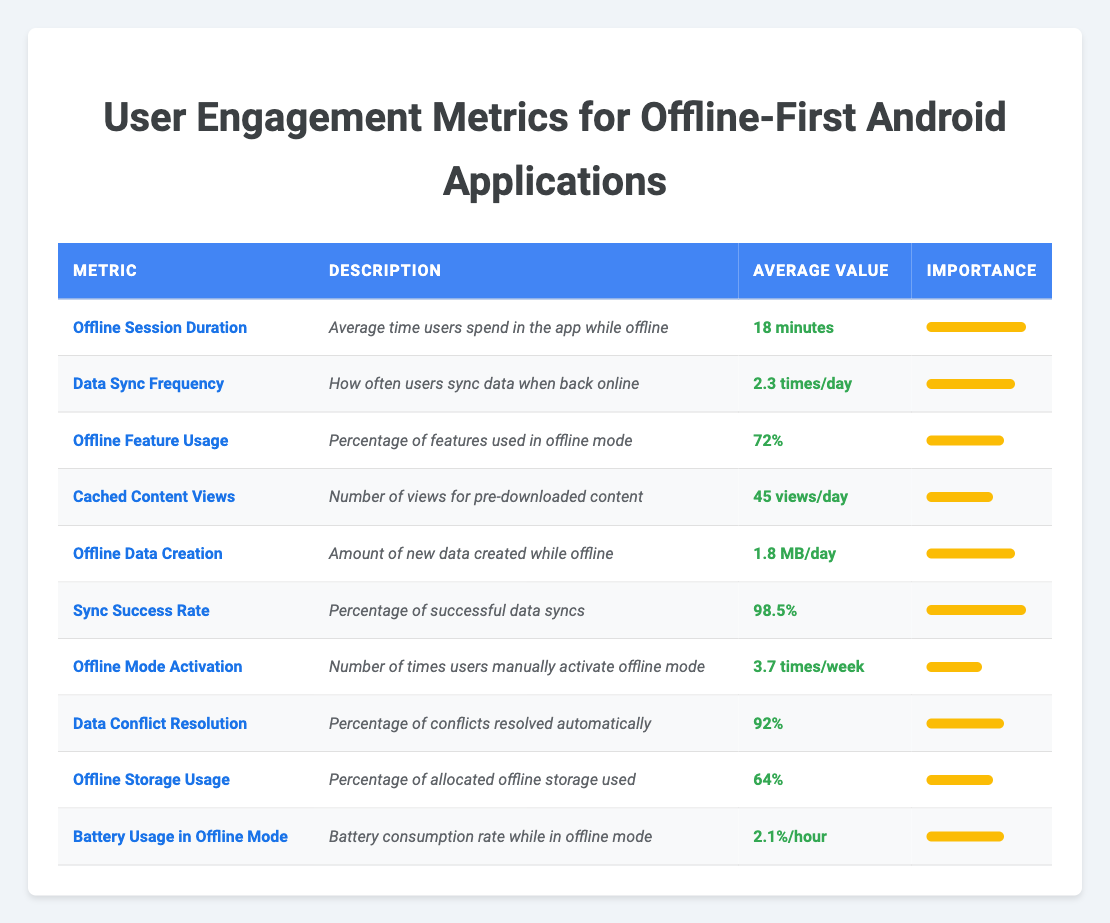What is the average value of Offline Session Duration? The average value for Offline Session Duration is provided directly in the table, which states it as "18 minutes."
Answer: 18 minutes How often do users sync data when back online (Data Sync Frequency)? The Data Sync Frequency is clearly listed in the table as "2.3 times/day." There are no calculations needed for this retrieval question.
Answer: 2.3 times/day Is the Sync Success Rate greater than or equal to 95%? The table shows the Sync Success Rate as "98.5%," which is indeed greater than 95%. Therefore, the answer is yes.
Answer: Yes What percentage of features are used in offline mode? According to the table, the Offline Feature Usage is "72%," which is a direct retrieval from the visual information.
Answer: 72% What is the difference in average values between Offline Session Duration and Cached Content Views? The Offline Session Duration is "18 minutes," while Cached Content Views is given as "45 views/day." To find the difference, note that one is in minutes and the other in views per day, so a direct subtraction isn't applicable. However, we can see that both metrics reflect user engagement in different ways. Hence, one can't compute a numerical difference directly. Thus no numeric value is provided for this question.
Answer: Not computable due to differing units How much new data is created daily while offline (Offline Data Creation)? In the table, the Offline Data Creation metric is listed as "1.8 MB/day," which is directly retrievable information.
Answer: 1.8 MB/day What is the average value of Offline Mode Activation per week? The value shown for Offline Mode Activation is "3.7 times/week," which presents a straightforward retrieval from the table.
Answer: 3.7 times/week What is the average battery usage in offline mode per hour? The table specifies the Battery Usage in Offline Mode as "2.1%/hour," making this a simple retrieval question.
Answer: 2.1%/hour Is the percentage of Automatic Data Conflict Resolution below 90%? The percentage of Automatic Data Conflict Resolution is shown in the table as "92%," which is above 90%. So, the answer is no.
Answer: No What is the average Offline Storage Usage and how does it compare to the importance rating? The average Offline Storage Usage is "64%," and its importance rating is "6." This means that it is moderately important, possibly indicating room for improvement in user engagement in this area.
Answer: 64%, Moderate Importance 